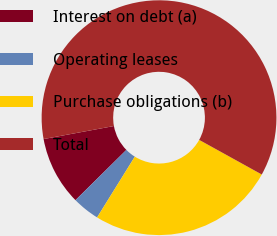Convert chart. <chart><loc_0><loc_0><loc_500><loc_500><pie_chart><fcel>Interest on debt (a)<fcel>Operating leases<fcel>Purchase obligations (b)<fcel>Total<nl><fcel>9.48%<fcel>3.76%<fcel>25.8%<fcel>60.95%<nl></chart> 